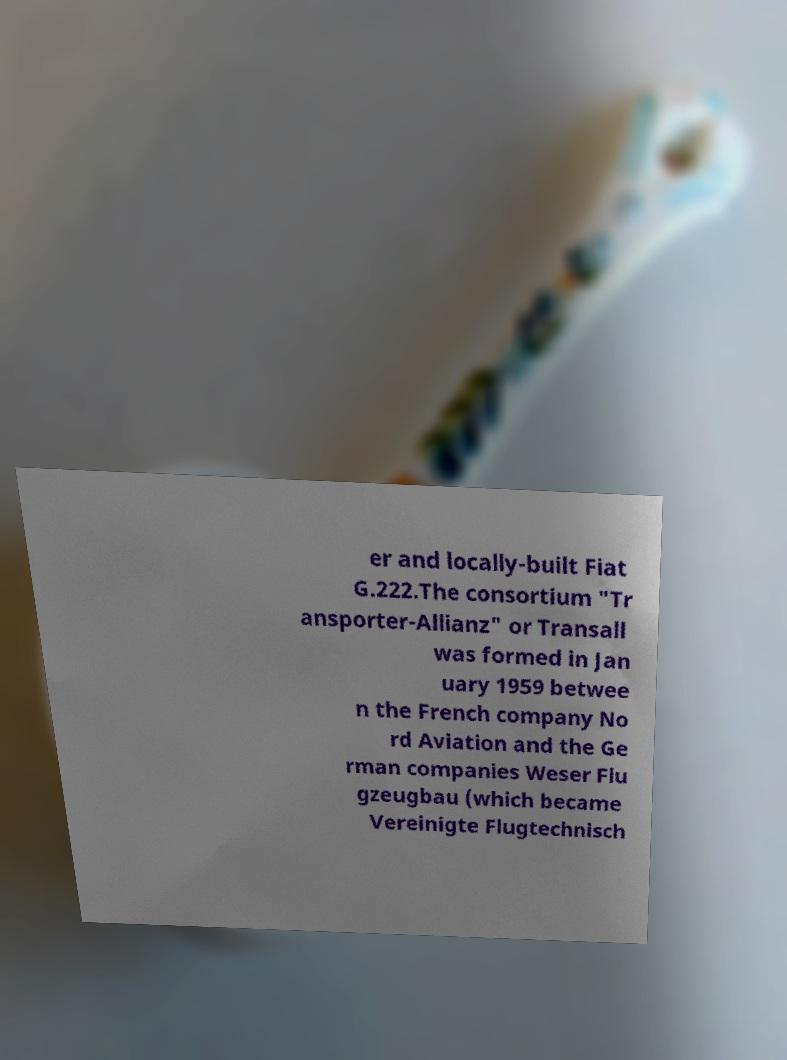What messages or text are displayed in this image? I need them in a readable, typed format. er and locally-built Fiat G.222.The consortium "Tr ansporter-Allianz" or Transall was formed in Jan uary 1959 betwee n the French company No rd Aviation and the Ge rman companies Weser Flu gzeugbau (which became Vereinigte Flugtechnisch 